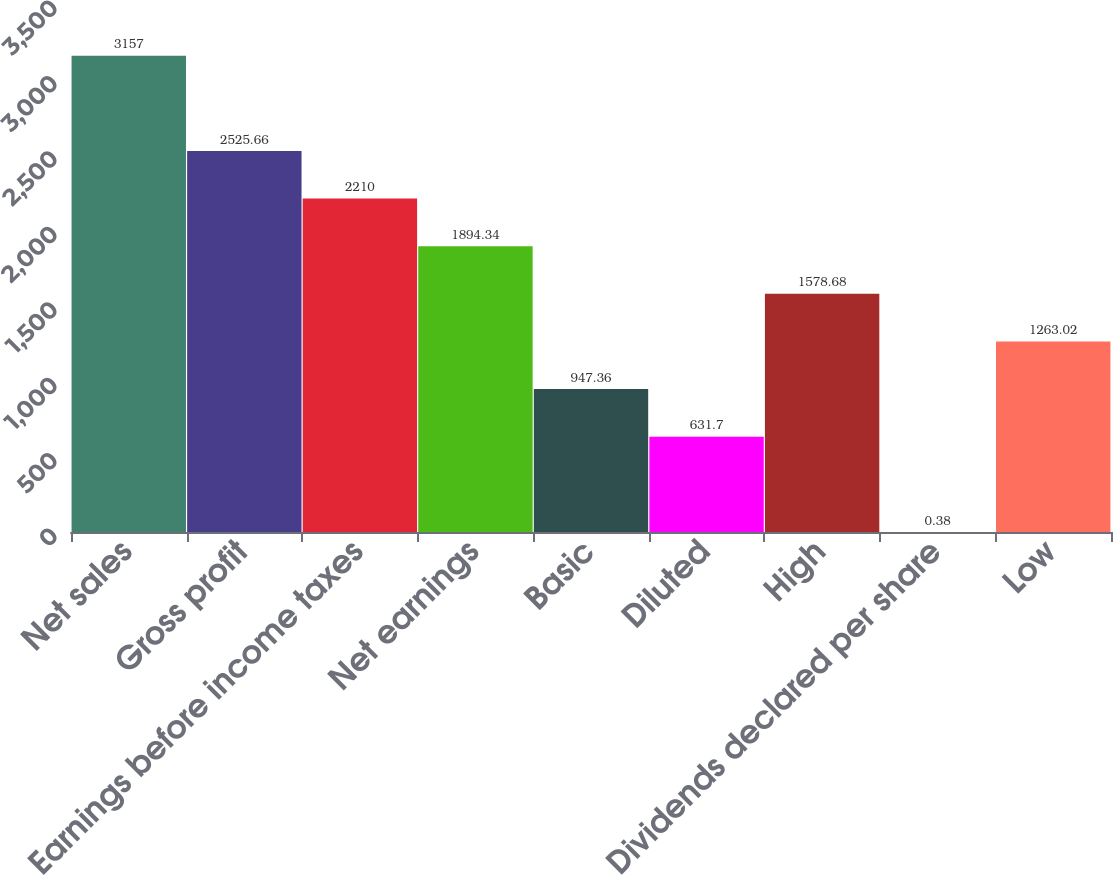Convert chart to OTSL. <chart><loc_0><loc_0><loc_500><loc_500><bar_chart><fcel>Net sales<fcel>Gross profit<fcel>Earnings before income taxes<fcel>Net earnings<fcel>Basic<fcel>Diluted<fcel>High<fcel>Dividends declared per share<fcel>Low<nl><fcel>3157<fcel>2525.66<fcel>2210<fcel>1894.34<fcel>947.36<fcel>631.7<fcel>1578.68<fcel>0.38<fcel>1263.02<nl></chart> 